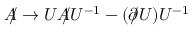Convert formula to latex. <formula><loc_0><loc_0><loc_500><loc_500>A \, / \rightarrow U A \, / U ^ { - 1 } - ( \partial \, / U ) U ^ { - 1 }</formula> 